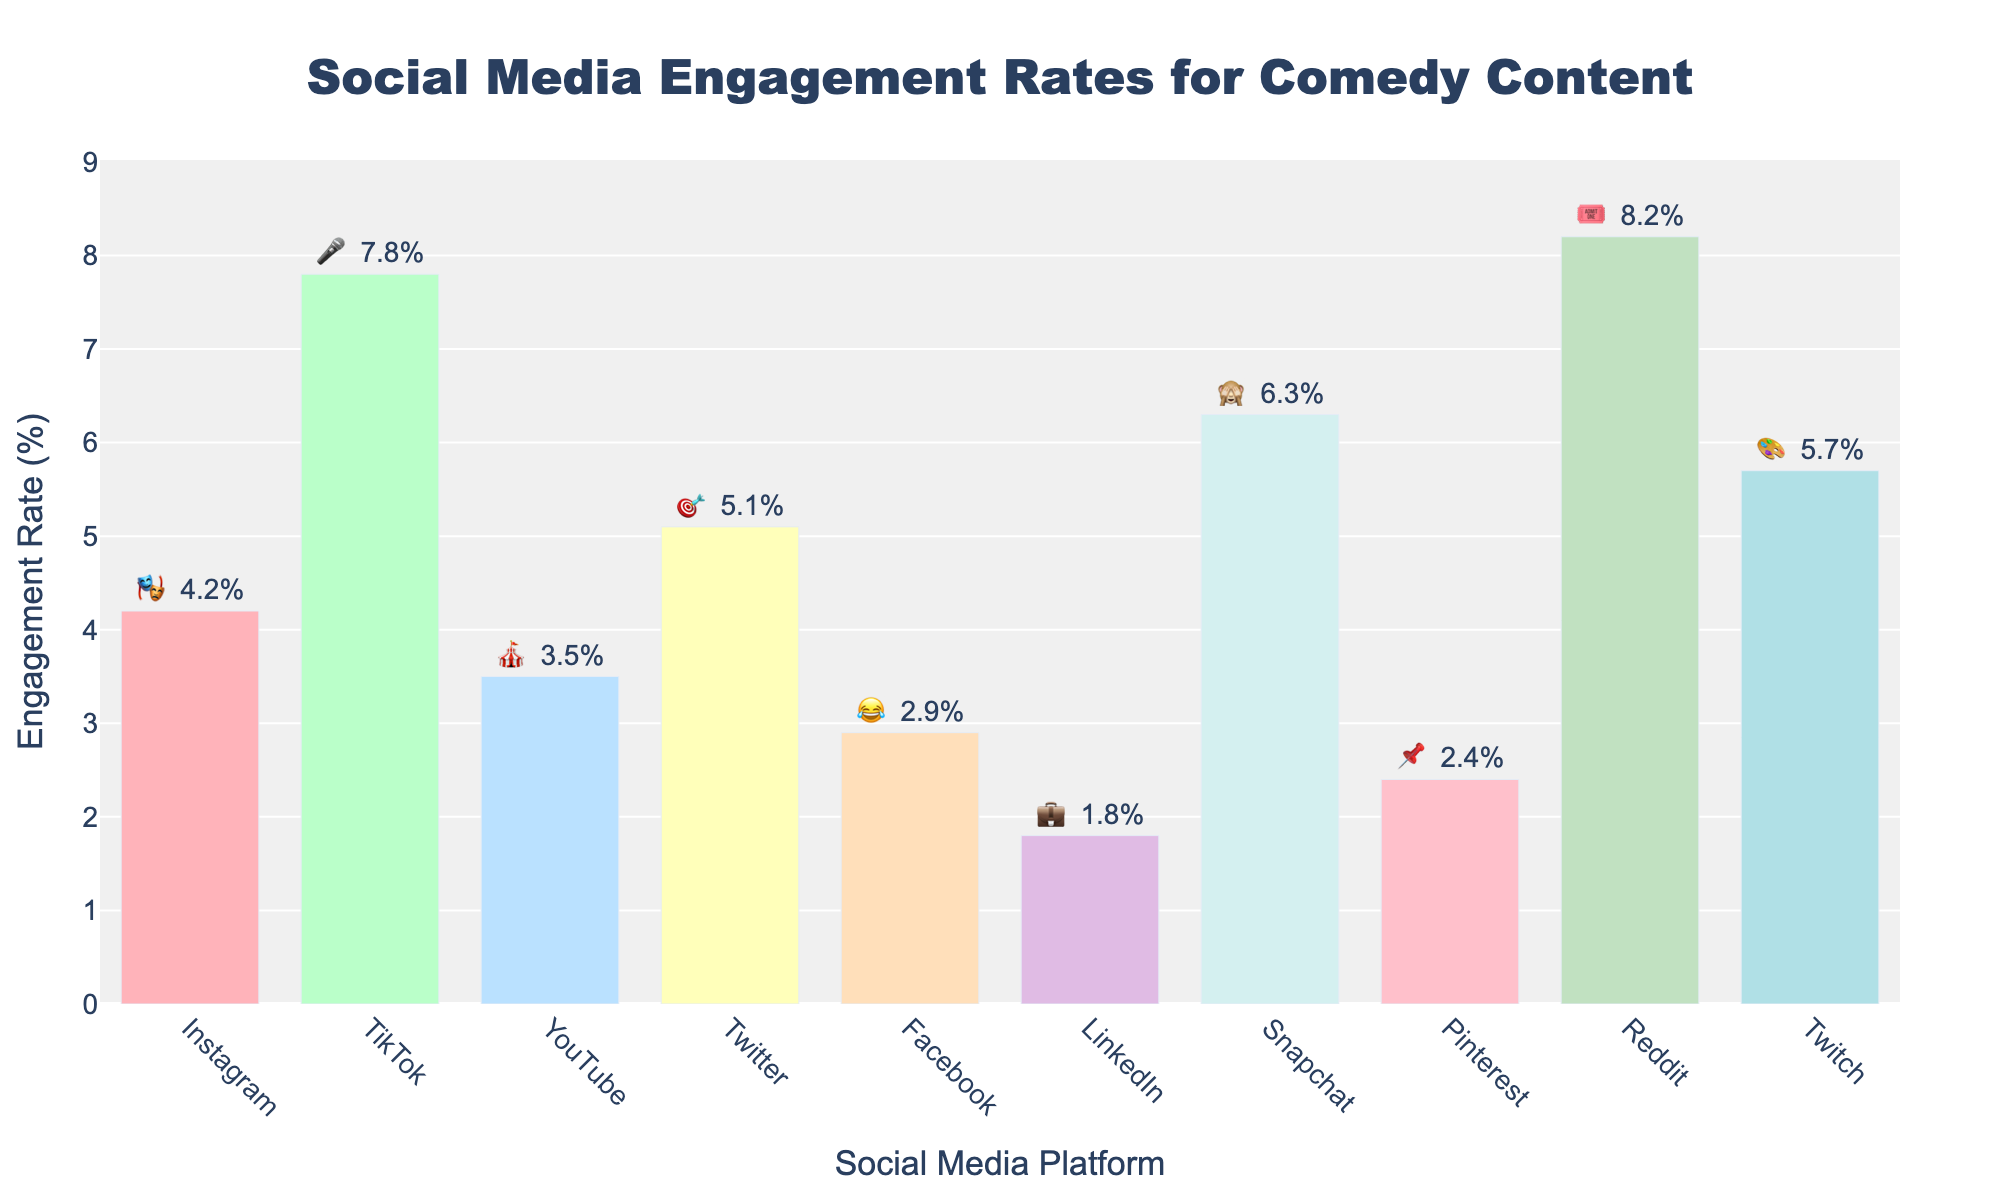Which platform has the highest engagement rate for comedic content? Check the y-axis values for all bars and identify the highest value. It shows Reddit with Funny Theater Anecdotes at 8.2%.
Answer: Reddit What is the engagement rate for Improv Challenges on TikTok? Locate TikTok on the x-axis and read the engagement rate noted outside the bar. It shows 7.8%.
Answer: 7.8% How does the engagement rate for Stand-up Routines on YouTube compare to Memes on Facebook? Find the engagement rates of both YouTube and Facebook from their respective bars; YouTube's is 3.5% and Facebook's is 2.9%. Compare the two rates.
Answer: YouTube > Facebook What’s the average engagement rate of the platforms represented in the chart? Sum all engagement rates and divide by the number of platforms: (4.2 + 7.8 + 3.5 + 5.1 + 2.9 + 1.8 + 6.3 + 2.4 + 8.2 + 5.7) / 10.
Answer: 4.79% Which content type on which platform has the emoji 🎤? Match the emoji 🎤 in the text outside bars to the platform. It matches TikTok and the content type is Improv Challenges.
Answer: TikTok, Improv Challenges How much higher is the engagement rate of One-liners on Twitter than Memes on Facebook? Subtract Facebook’s rate (2.9%) from Twitter’s rate (5.1%).
Answer: 2.2% If we combine the engagement rates for Instagram, Snapchat, and Pinterest, what’s the total? Summing up the rates: 4.2% (Instagram) + 6.3% (Snapchat) + 2.4% (Pinterest).
Answer: 12.9% Which has a higher engagement rate: Humorous Work Stories on LinkedIn or Stand-up Routines on YouTube? Compare LinkedIn’s engagement rate (1.8%) with YouTube’s (3.5%).
Answer: YouTube What is the engagement rate difference between the highest and the lowest performing platforms? Find the rates for the highest (Reddit at 8.2%) and the lowest (LinkedIn at 1.8%), then subtract the latter from the former.
Answer: 6.4% How many platforms have engagement rates below the overall average of 4.79%? Identify and count platforms with rates below 4.79%. These platforms are YouTube (3.5%), Facebook (2.9%), LinkedIn (1.8%), and Pinterest (2.4%).
Answer: Four 